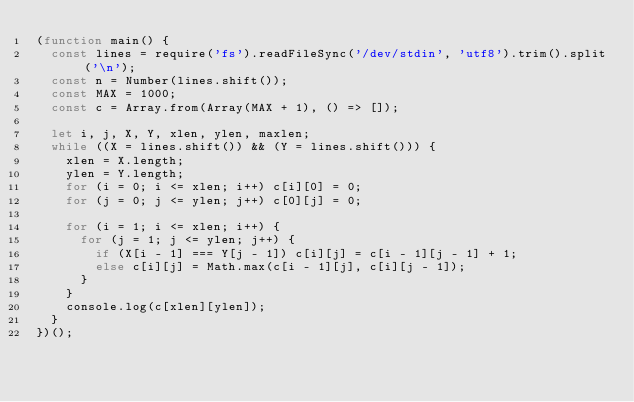Convert code to text. <code><loc_0><loc_0><loc_500><loc_500><_JavaScript_>(function main() {
  const lines = require('fs').readFileSync('/dev/stdin', 'utf8').trim().split('\n');
  const n = Number(lines.shift());
  const MAX = 1000;
  const c = Array.from(Array(MAX + 1), () => []);

  let i, j, X, Y, xlen, ylen, maxlen;
  while ((X = lines.shift()) && (Y = lines.shift())) {
    xlen = X.length;
    ylen = Y.length;
    for (i = 0; i <= xlen; i++) c[i][0] = 0;
    for (j = 0; j <= ylen; j++) c[0][j] = 0;

    for (i = 1; i <= xlen; i++) {
      for (j = 1; j <= ylen; j++) {
        if (X[i - 1] === Y[j - 1]) c[i][j] = c[i - 1][j - 1] + 1;
        else c[i][j] = Math.max(c[i - 1][j], c[i][j - 1]);
      }
    }
    console.log(c[xlen][ylen]);
  }
})();

</code> 